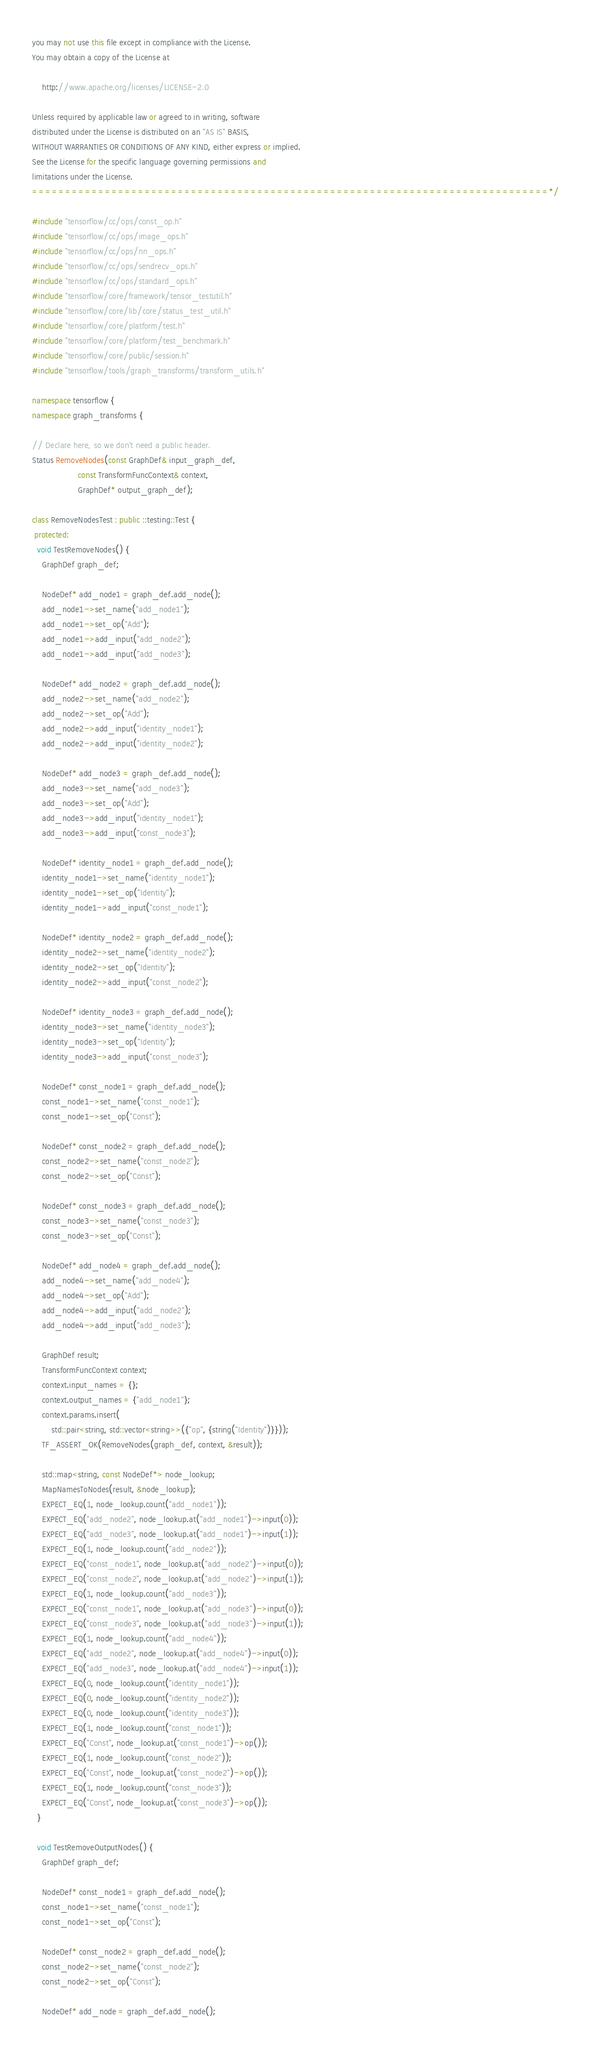<code> <loc_0><loc_0><loc_500><loc_500><_C++_>you may not use this file except in compliance with the License.
You may obtain a copy of the License at

    http://www.apache.org/licenses/LICENSE-2.0

Unless required by applicable law or agreed to in writing, software
distributed under the License is distributed on an "AS IS" BASIS,
WITHOUT WARRANTIES OR CONDITIONS OF ANY KIND, either express or implied.
See the License for the specific language governing permissions and
limitations under the License.
==============================================================================*/

#include "tensorflow/cc/ops/const_op.h"
#include "tensorflow/cc/ops/image_ops.h"
#include "tensorflow/cc/ops/nn_ops.h"
#include "tensorflow/cc/ops/sendrecv_ops.h"
#include "tensorflow/cc/ops/standard_ops.h"
#include "tensorflow/core/framework/tensor_testutil.h"
#include "tensorflow/core/lib/core/status_test_util.h"
#include "tensorflow/core/platform/test.h"
#include "tensorflow/core/platform/test_benchmark.h"
#include "tensorflow/core/public/session.h"
#include "tensorflow/tools/graph_transforms/transform_utils.h"

namespace tensorflow {
namespace graph_transforms {

// Declare here, so we don't need a public header.
Status RemoveNodes(const GraphDef& input_graph_def,
                   const TransformFuncContext& context,
                   GraphDef* output_graph_def);

class RemoveNodesTest : public ::testing::Test {
 protected:
  void TestRemoveNodes() {
    GraphDef graph_def;

    NodeDef* add_node1 = graph_def.add_node();
    add_node1->set_name("add_node1");
    add_node1->set_op("Add");
    add_node1->add_input("add_node2");
    add_node1->add_input("add_node3");

    NodeDef* add_node2 = graph_def.add_node();
    add_node2->set_name("add_node2");
    add_node2->set_op("Add");
    add_node2->add_input("identity_node1");
    add_node2->add_input("identity_node2");

    NodeDef* add_node3 = graph_def.add_node();
    add_node3->set_name("add_node3");
    add_node3->set_op("Add");
    add_node3->add_input("identity_node1");
    add_node3->add_input("const_node3");

    NodeDef* identity_node1 = graph_def.add_node();
    identity_node1->set_name("identity_node1");
    identity_node1->set_op("Identity");
    identity_node1->add_input("const_node1");

    NodeDef* identity_node2 = graph_def.add_node();
    identity_node2->set_name("identity_node2");
    identity_node2->set_op("Identity");
    identity_node2->add_input("const_node2");

    NodeDef* identity_node3 = graph_def.add_node();
    identity_node3->set_name("identity_node3");
    identity_node3->set_op("Identity");
    identity_node3->add_input("const_node3");

    NodeDef* const_node1 = graph_def.add_node();
    const_node1->set_name("const_node1");
    const_node1->set_op("Const");

    NodeDef* const_node2 = graph_def.add_node();
    const_node2->set_name("const_node2");
    const_node2->set_op("Const");

    NodeDef* const_node3 = graph_def.add_node();
    const_node3->set_name("const_node3");
    const_node3->set_op("Const");

    NodeDef* add_node4 = graph_def.add_node();
    add_node4->set_name("add_node4");
    add_node4->set_op("Add");
    add_node4->add_input("add_node2");
    add_node4->add_input("add_node3");

    GraphDef result;
    TransformFuncContext context;
    context.input_names = {};
    context.output_names = {"add_node1"};
    context.params.insert(
        std::pair<string, std::vector<string>>({"op", {string("Identity")}}));
    TF_ASSERT_OK(RemoveNodes(graph_def, context, &result));

    std::map<string, const NodeDef*> node_lookup;
    MapNamesToNodes(result, &node_lookup);
    EXPECT_EQ(1, node_lookup.count("add_node1"));
    EXPECT_EQ("add_node2", node_lookup.at("add_node1")->input(0));
    EXPECT_EQ("add_node3", node_lookup.at("add_node1")->input(1));
    EXPECT_EQ(1, node_lookup.count("add_node2"));
    EXPECT_EQ("const_node1", node_lookup.at("add_node2")->input(0));
    EXPECT_EQ("const_node2", node_lookup.at("add_node2")->input(1));
    EXPECT_EQ(1, node_lookup.count("add_node3"));
    EXPECT_EQ("const_node1", node_lookup.at("add_node3")->input(0));
    EXPECT_EQ("const_node3", node_lookup.at("add_node3")->input(1));
    EXPECT_EQ(1, node_lookup.count("add_node4"));
    EXPECT_EQ("add_node2", node_lookup.at("add_node4")->input(0));
    EXPECT_EQ("add_node3", node_lookup.at("add_node4")->input(1));
    EXPECT_EQ(0, node_lookup.count("identity_node1"));
    EXPECT_EQ(0, node_lookup.count("identity_node2"));
    EXPECT_EQ(0, node_lookup.count("identity_node3"));
    EXPECT_EQ(1, node_lookup.count("const_node1"));
    EXPECT_EQ("Const", node_lookup.at("const_node1")->op());
    EXPECT_EQ(1, node_lookup.count("const_node2"));
    EXPECT_EQ("Const", node_lookup.at("const_node2")->op());
    EXPECT_EQ(1, node_lookup.count("const_node3"));
    EXPECT_EQ("Const", node_lookup.at("const_node3")->op());
  }

  void TestRemoveOutputNodes() {
    GraphDef graph_def;

    NodeDef* const_node1 = graph_def.add_node();
    const_node1->set_name("const_node1");
    const_node1->set_op("Const");

    NodeDef* const_node2 = graph_def.add_node();
    const_node2->set_name("const_node2");
    const_node2->set_op("Const");

    NodeDef* add_node = graph_def.add_node();</code> 